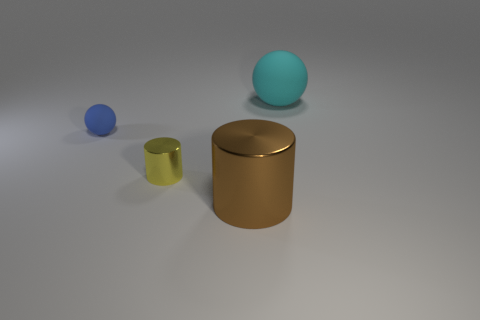Add 4 balls. How many objects exist? 8 Add 1 large brown cylinders. How many large brown cylinders are left? 2 Add 1 small brown cylinders. How many small brown cylinders exist? 1 Subtract 0 green cylinders. How many objects are left? 4 Subtract all blue cylinders. Subtract all brown balls. How many cylinders are left? 2 Subtract all yellow shiny cylinders. Subtract all large brown cylinders. How many objects are left? 2 